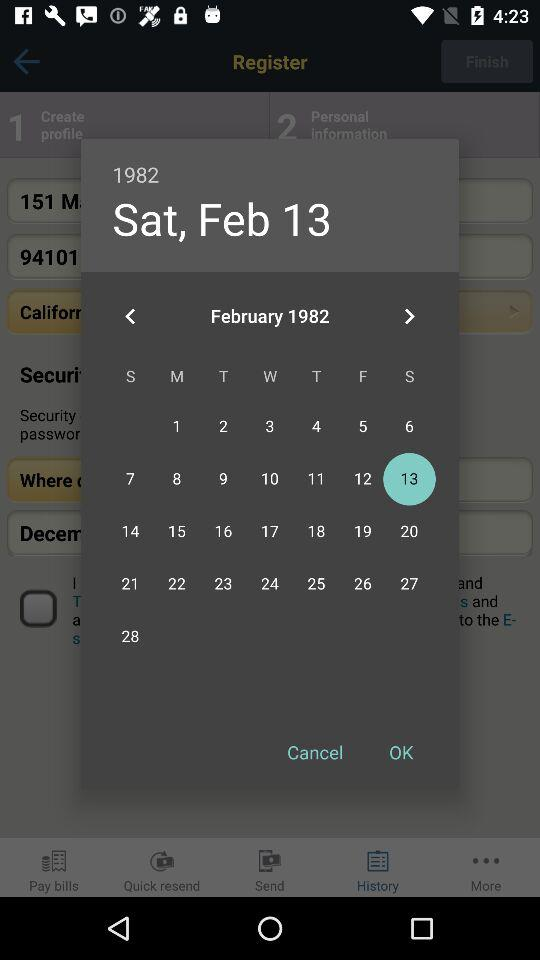Which date has been selected? The selected date is Saturday, February 13, 1982. 